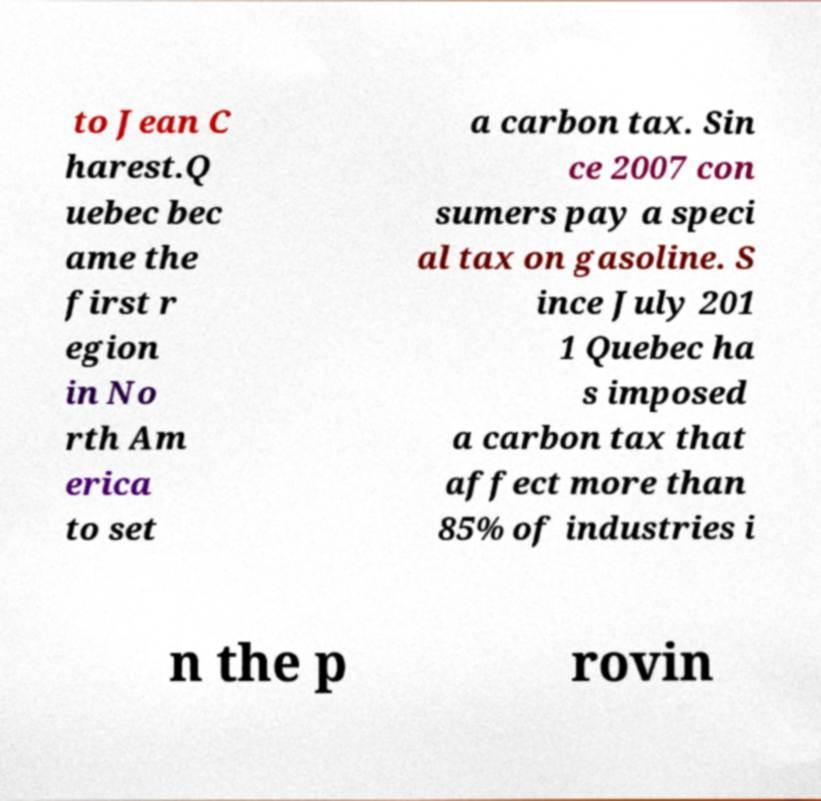Please read and relay the text visible in this image. What does it say? to Jean C harest.Q uebec bec ame the first r egion in No rth Am erica to set a carbon tax. Sin ce 2007 con sumers pay a speci al tax on gasoline. S ince July 201 1 Quebec ha s imposed a carbon tax that affect more than 85% of industries i n the p rovin 